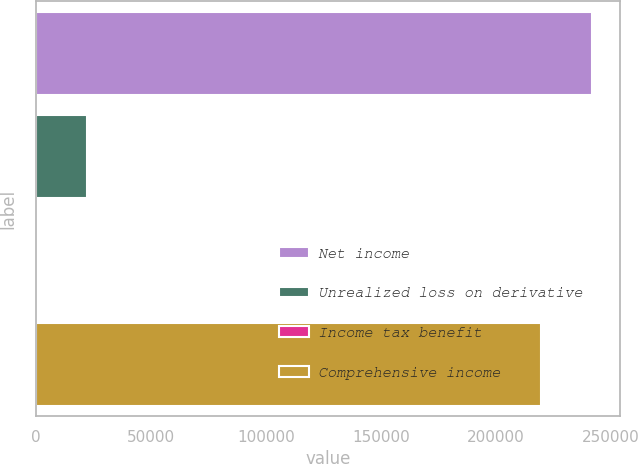Convert chart to OTSL. <chart><loc_0><loc_0><loc_500><loc_500><bar_chart><fcel>Net income<fcel>Unrealized loss on derivative<fcel>Income tax benefit<fcel>Comprehensive income<nl><fcel>241790<fcel>22080.7<fcel>95<fcel>219804<nl></chart> 